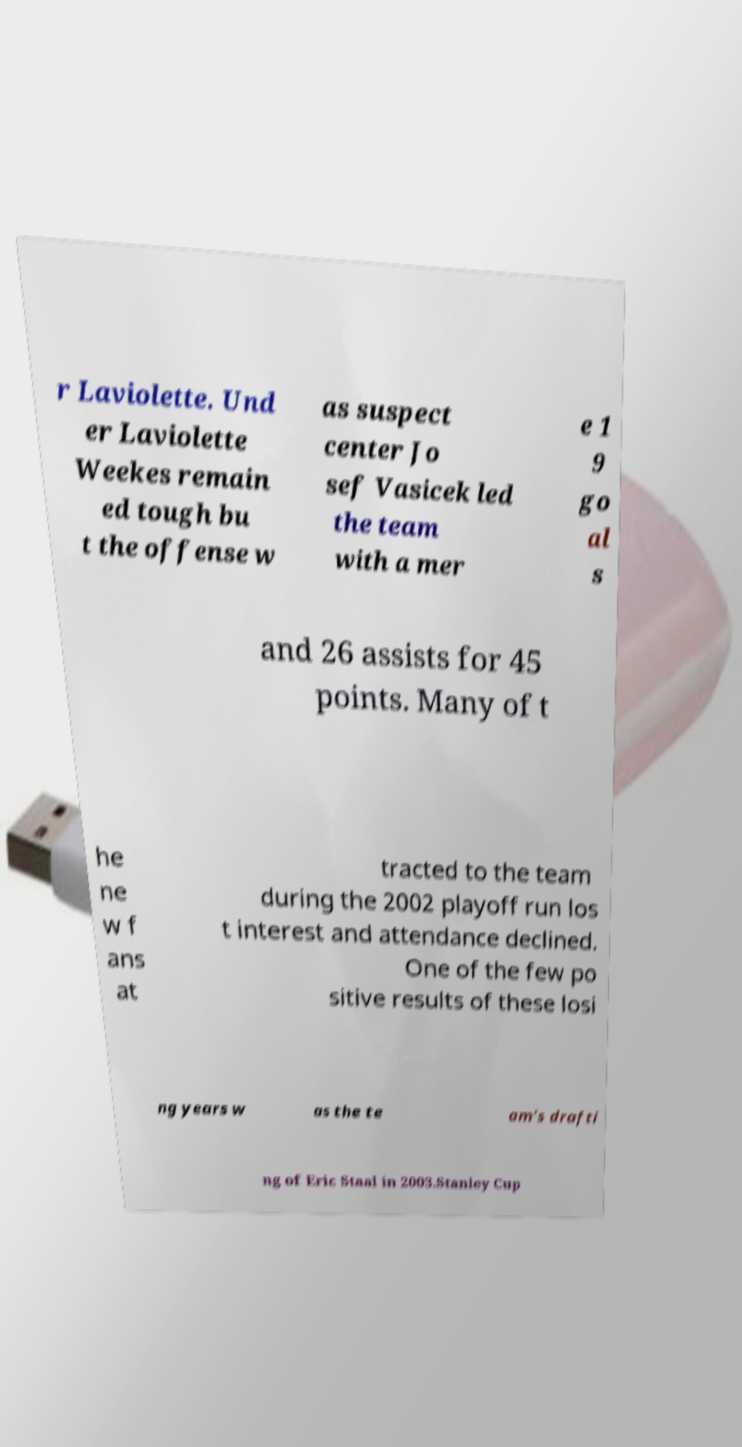For documentation purposes, I need the text within this image transcribed. Could you provide that? r Laviolette. Und er Laviolette Weekes remain ed tough bu t the offense w as suspect center Jo sef Vasicek led the team with a mer e 1 9 go al s and 26 assists for 45 points. Many of t he ne w f ans at tracted to the team during the 2002 playoff run los t interest and attendance declined. One of the few po sitive results of these losi ng years w as the te am's drafti ng of Eric Staal in 2003.Stanley Cup 